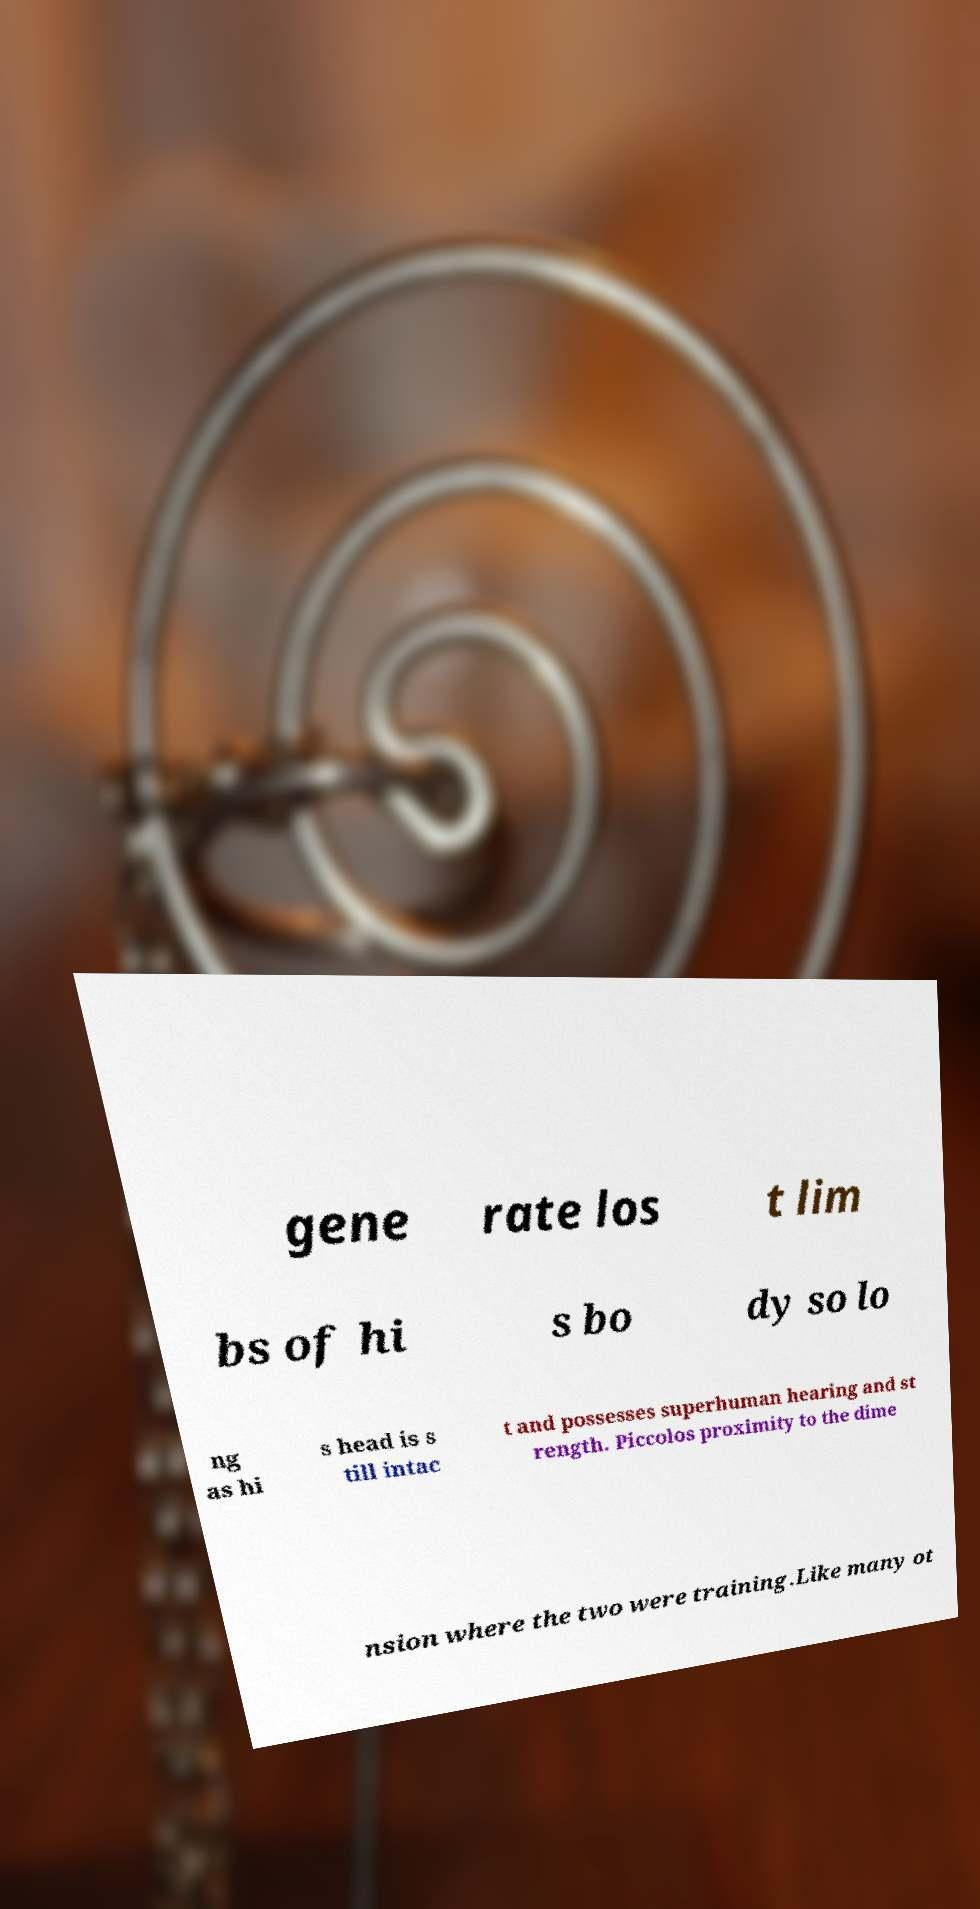Could you extract and type out the text from this image? gene rate los t lim bs of hi s bo dy so lo ng as hi s head is s till intac t and possesses superhuman hearing and st rength. Piccolos proximity to the dime nsion where the two were training.Like many ot 